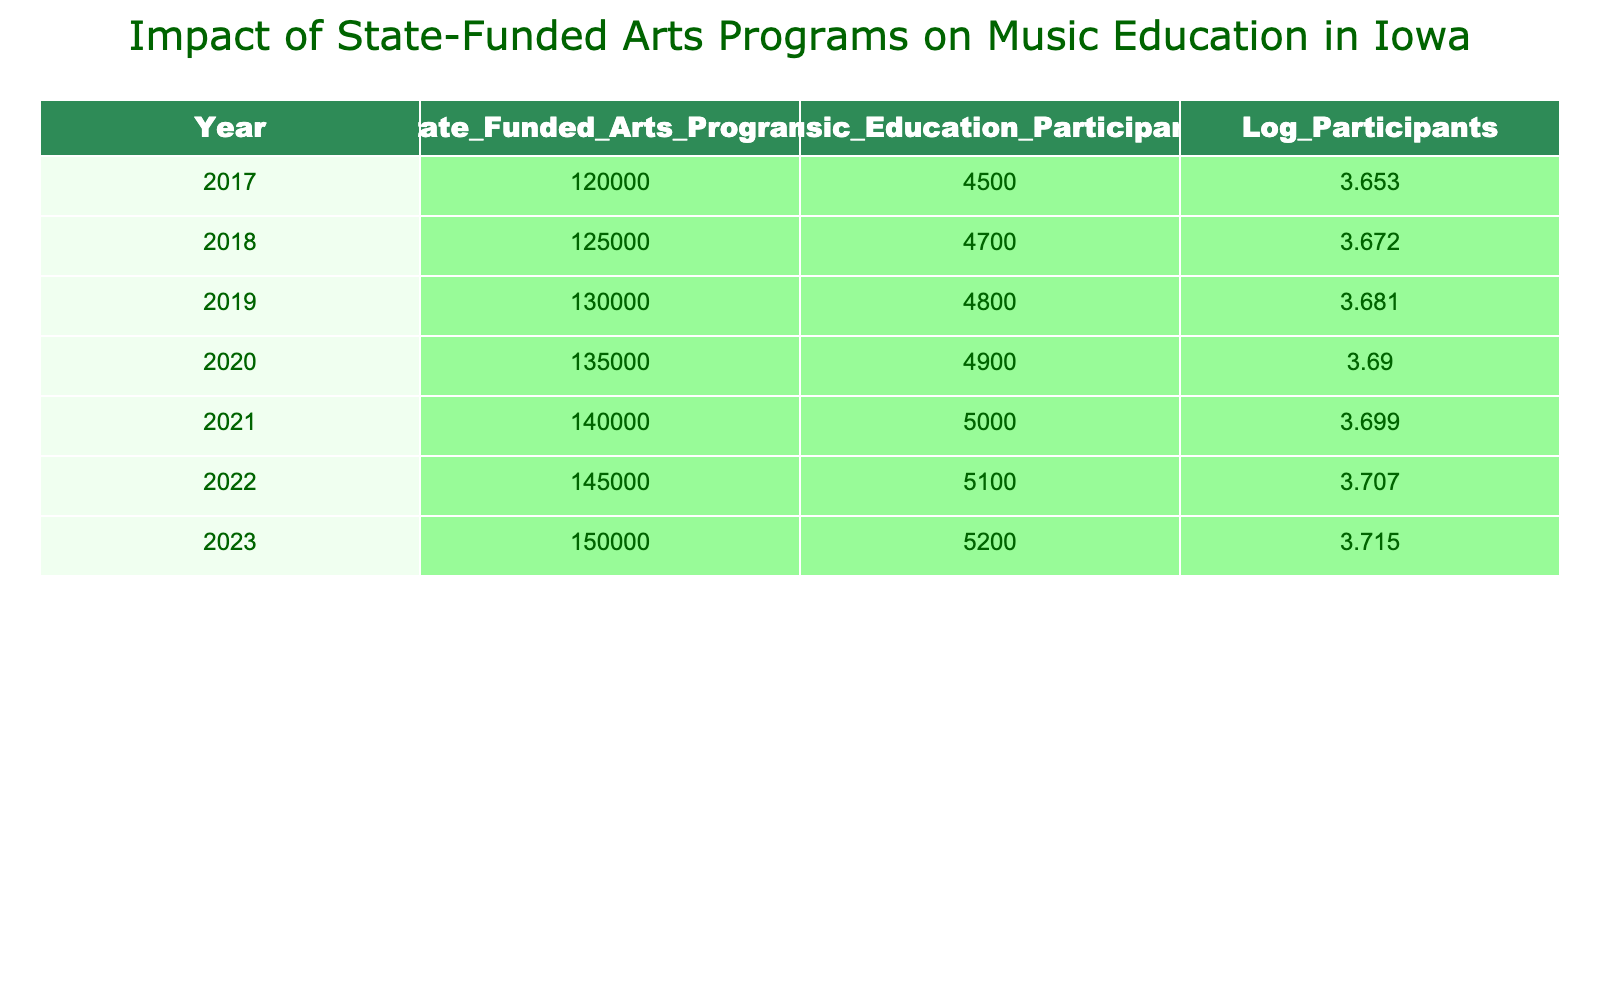What was the total funding for state-funded arts programs in Iowa in 2022? From the table, the value for state-funded arts programs in the year 2022 is 145000. This value is directly retrieved from the corresponding row in the table.
Answer: 145000 In which year did music education participation first exceed 5000? Looking at the year-by-year values for music education participants, we find that the first instance where the number exceeds 5000 is in the year 2021. This indicates a transition occurred in that year.
Answer: 2021 What is the difference in music education participants between 2017 and 2023? The number of music education participants in 2017 was 4500 and in 2023 it was 5200. The difference is calculated by subtracting the earlier year's value from the later year's value, which is 5200 - 4500 = 700.
Answer: 700 Was there an increase in participants from 2020 to 2021? In 2020, the number of participants was 4900 and in 2021 it was 5000. Since 5000 is higher than 4900, we can conclude that there was indeed an increase.
Answer: Yes What was the average number of music education participants from 2017 to 2023? To find the average, we first need to sum the number of participants from each year: 4500 + 4700 + 4800 + 4900 + 5000 + 5100 + 5200 = 32700. Since there are 7 years of data, we divide the sum by 7: 32700 / 7 = 4671.43.
Answer: 4671.43 If the funding for state-funded arts programs was 135000 in 2020, what was the funding growth by 2023? The funding in 2020 was 135000, and in 2023 it increased to 150000. To calculate the growth, we subtract the earlier value from the later one: 150000 - 135000 = 15000. Thus, the growth in funding over this period is calculated.
Answer: 15000 Was music education participation consistently increasing from 2017 to 2023? We can look at the participant numbers for each year: 4500, 4700, 4800, 4900, 5000, 5100, 5200. Since each subsequent year shows a higher number than the previous, we confirm that participation was consistently increasing during this period.
Answer: Yes What were the log participants in 2019? The value for log participants in 2019 is directly available in the table, which is 3.681. This value can be directly retrieved without further calculations.
Answer: 3.681 How much did the state-funded arts programs increase their funding from 2018 to 2022? The funding for state-funded arts programs in 2018 was 125000 and in 2022 it was 145000. To find the increase, we calculate: 145000 - 125000 = 20000. Therefore, the increase in funding over these years can be determined through this calculation.
Answer: 20000 